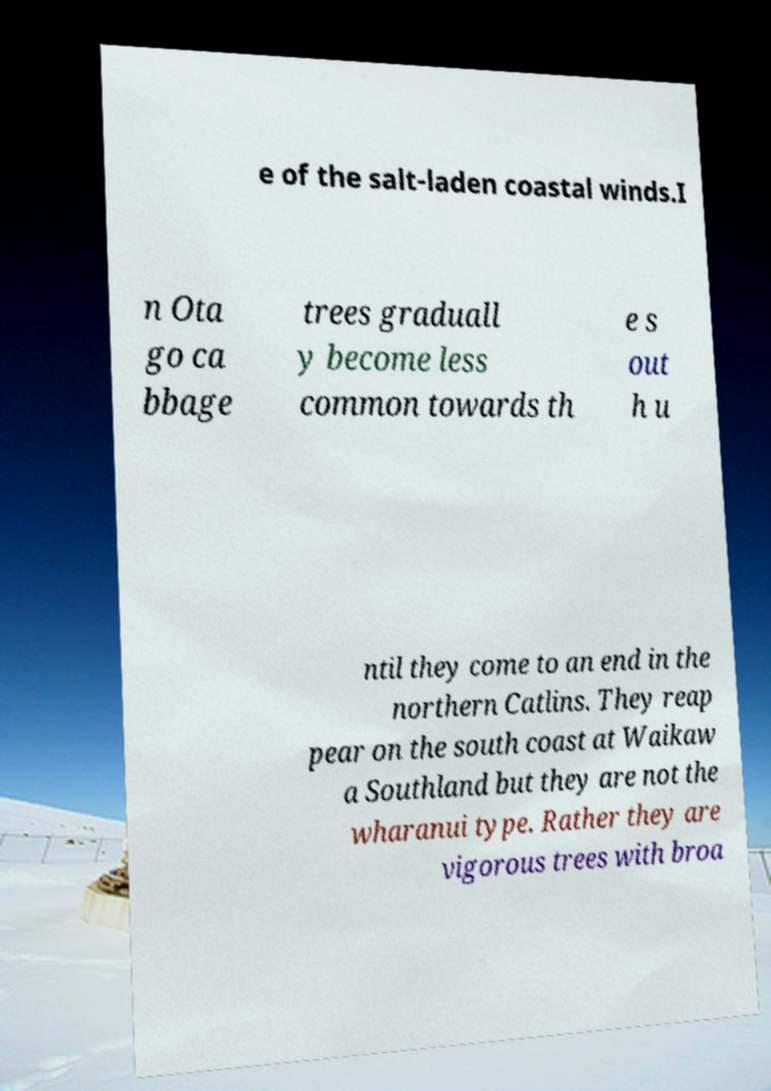There's text embedded in this image that I need extracted. Can you transcribe it verbatim? e of the salt-laden coastal winds.I n Ota go ca bbage trees graduall y become less common towards th e s out h u ntil they come to an end in the northern Catlins. They reap pear on the south coast at Waikaw a Southland but they are not the wharanui type. Rather they are vigorous trees with broa 